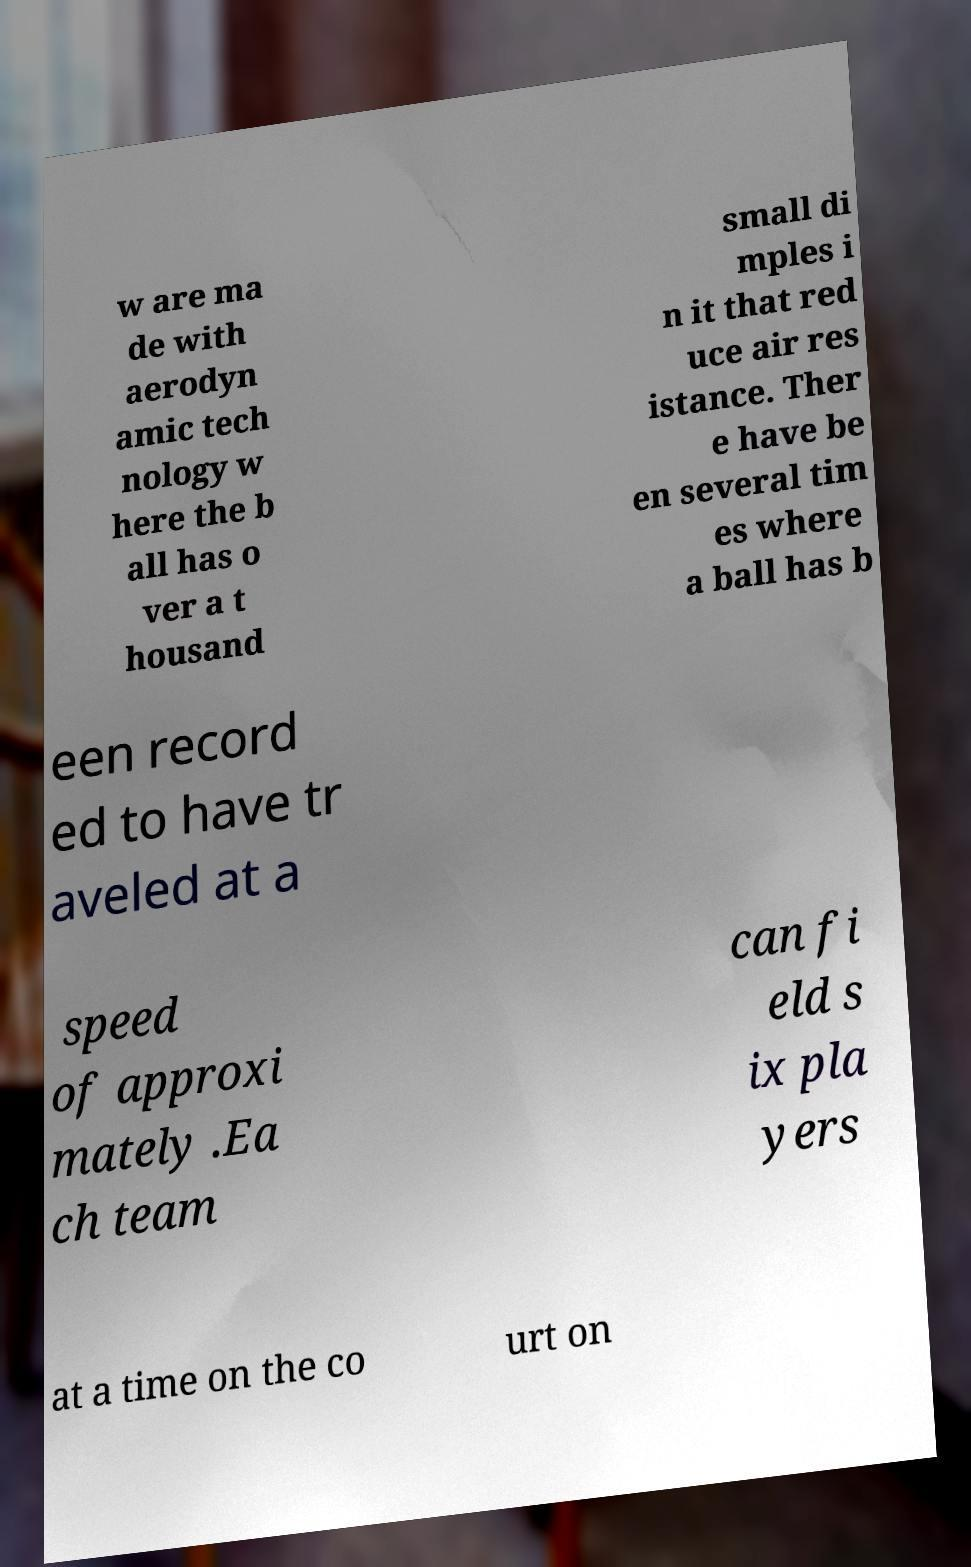Could you extract and type out the text from this image? w are ma de with aerodyn amic tech nology w here the b all has o ver a t housand small di mples i n it that red uce air res istance. Ther e have be en several tim es where a ball has b een record ed to have tr aveled at a speed of approxi mately .Ea ch team can fi eld s ix pla yers at a time on the co urt on 